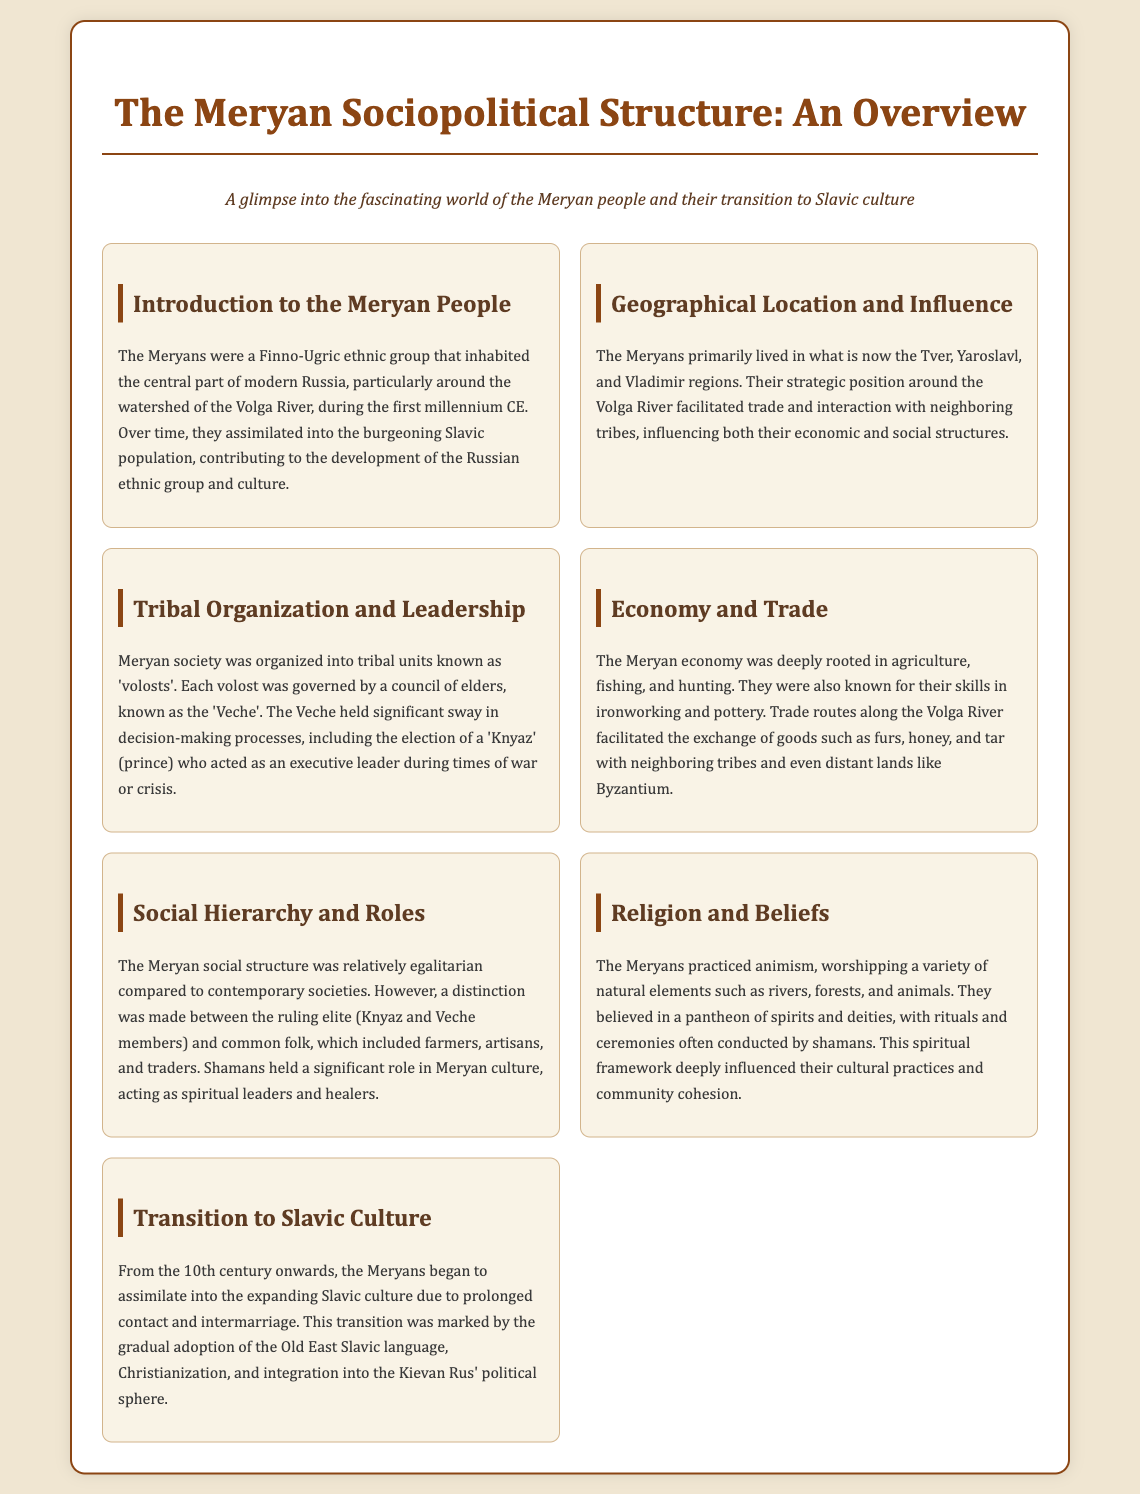What ethnic group inhabited central Russia? The Meryans were a Finno-Ugric ethnic group that inhabited the central part of modern Russia.
Answer: Meryans What regions did the Meryans primarily live in? The Meryans primarily lived in the Tver, Yaroslavl, and Vladimir regions.
Answer: Tver, Yaroslavl, and Vladimir What was the governing council of each volost called? Each volost was governed by a council of elders known as the 'Veche'.
Answer: Veche What economic activities were the Meryans involved in? The Meryan economy was deeply rooted in agriculture, fishing, and hunting.
Answer: Agriculture, fishing, and hunting What religious practice did the Meryans follow? The Meryans practiced animism, worshipping a variety of natural elements.
Answer: Animism In which century did the Meryans begin to assimilate into Slavic culture? The Meryans began to assimilate into the expanding Slavic culture from the 10th century onwards.
Answer: 10th century Why did the Meryans have influence in trade? Their strategic position around the Volga River facilitated trade and interaction with neighboring tribes.
Answer: Strategic position around the Volga River What role did shamans have in Meryan society? Shamans acted as spiritual leaders and healers in Meryan culture.
Answer: Spiritual leaders and healers What marked the transition to Slavic culture for the Meryans? The transition was marked by the gradual adoption of the Old East Slavic language and Christianization.
Answer: Adoption of the Old East Slavic language and Christianization 